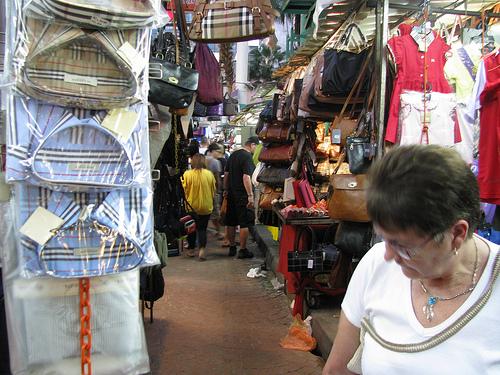<image>
Is there a chain to the right of the woman? No. The chain is not to the right of the woman. The horizontal positioning shows a different relationship. 